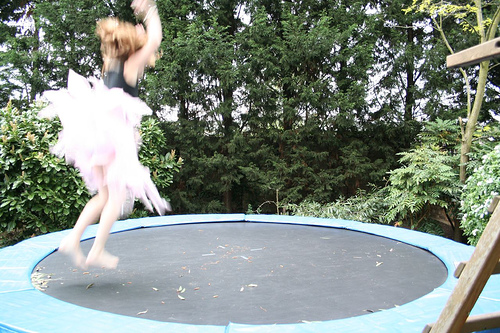What is the person doing? The person is captured in mid-air while jumping on a trampoline, creating a sense of joyful energy and movement. Can you describe their attire? The person is wearing a light-colored, possibly pink, skirt often associated with a ballet costume, suggesting they might be practicing dance moves or just enjoying a playful moment. 